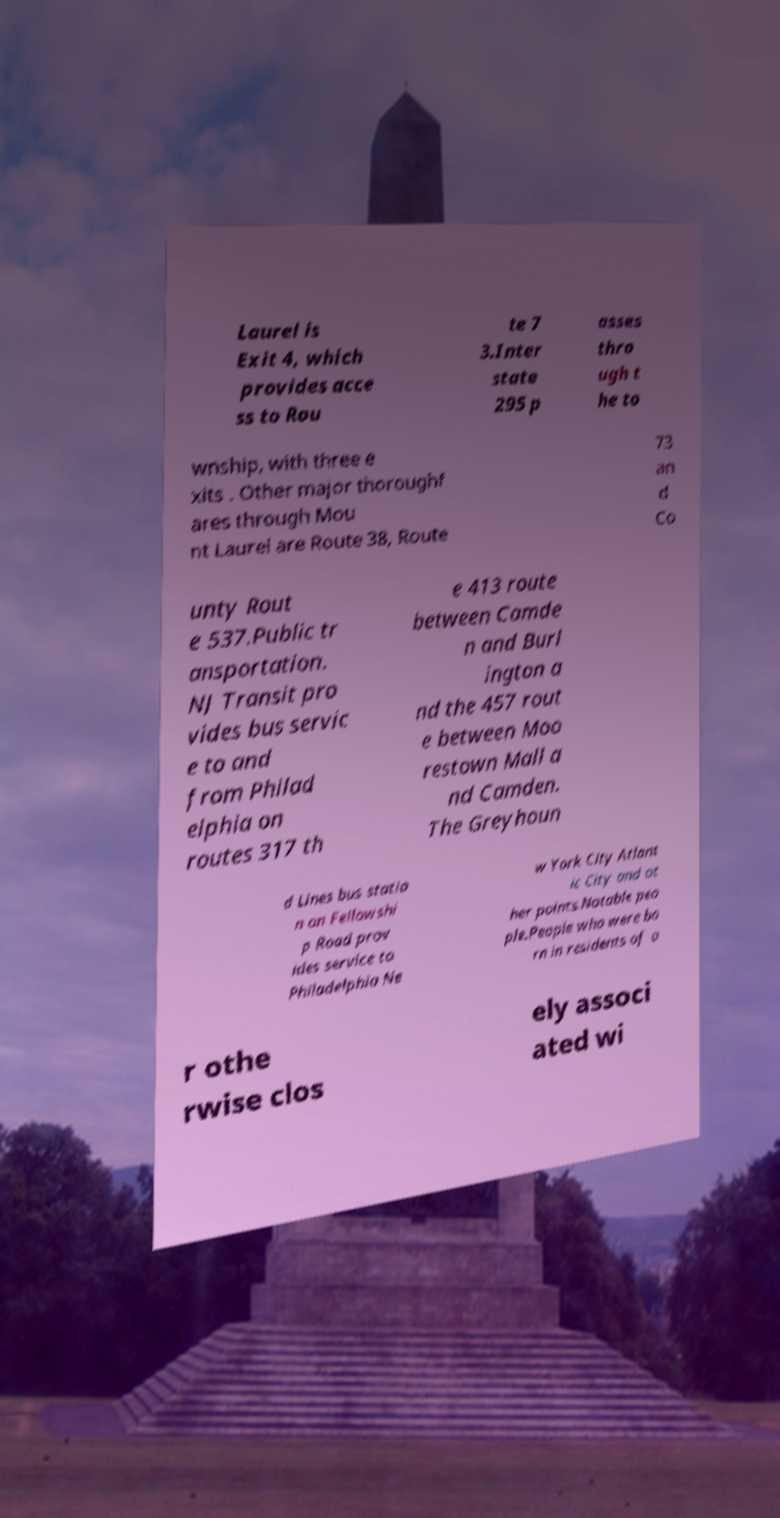For documentation purposes, I need the text within this image transcribed. Could you provide that? Laurel is Exit 4, which provides acce ss to Rou te 7 3.Inter state 295 p asses thro ugh t he to wnship, with three e xits . Other major thoroughf ares through Mou nt Laurel are Route 38, Route 73 an d Co unty Rout e 537.Public tr ansportation. NJ Transit pro vides bus servic e to and from Philad elphia on routes 317 th e 413 route between Camde n and Burl ington a nd the 457 rout e between Moo restown Mall a nd Camden. The Greyhoun d Lines bus statio n on Fellowshi p Road prov ides service to Philadelphia Ne w York City Atlant ic City and ot her points.Notable peo ple.People who were bo rn in residents of o r othe rwise clos ely associ ated wi 